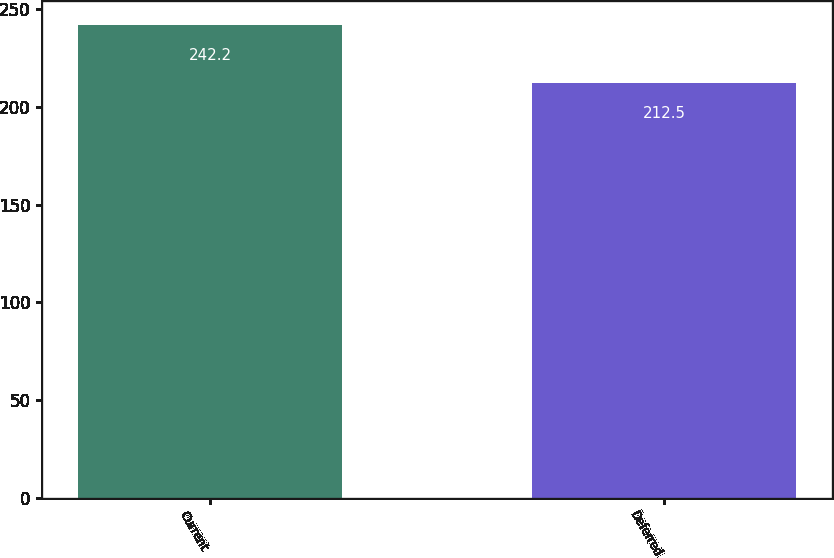Convert chart to OTSL. <chart><loc_0><loc_0><loc_500><loc_500><bar_chart><fcel>Current<fcel>Deferred<nl><fcel>242.2<fcel>212.5<nl></chart> 